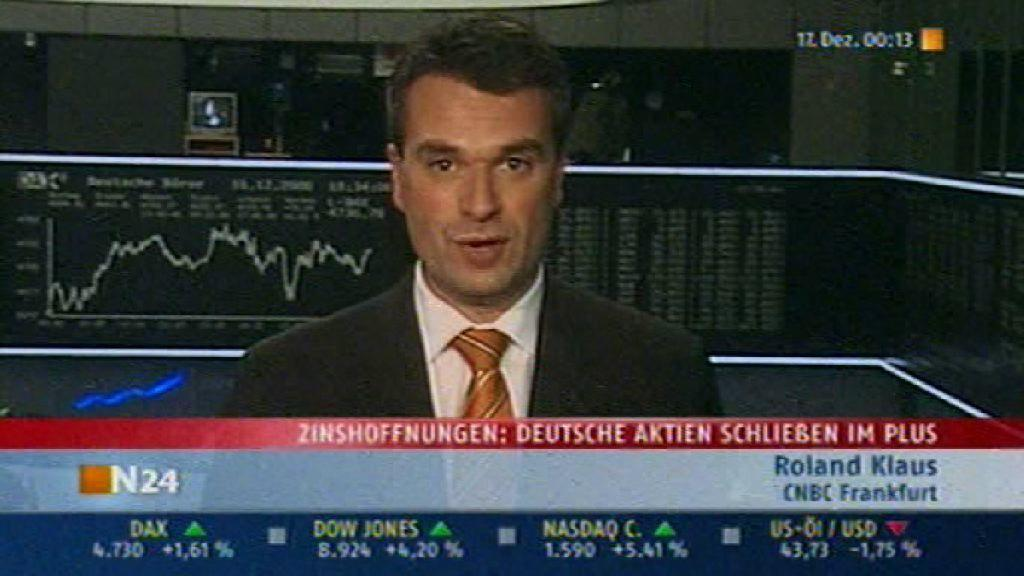Who is present in the image? There is a man in the image. What is the man wearing on his upper body? The man is wearing a black blazer and a white shirt. Is there any accessory visible on the man? Yes, the man is wearing a tie. What else can be seen in the image besides the man? There is writing visible in the image at multiple places. What type of appliance is the man using to cut the wine in the image? There is no appliance, knife, or wine present in the image. 